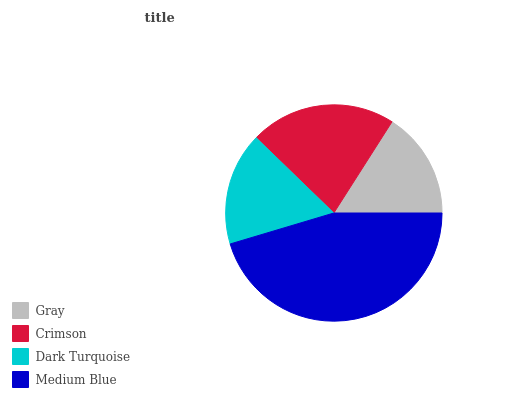Is Gray the minimum?
Answer yes or no. Yes. Is Medium Blue the maximum?
Answer yes or no. Yes. Is Crimson the minimum?
Answer yes or no. No. Is Crimson the maximum?
Answer yes or no. No. Is Crimson greater than Gray?
Answer yes or no. Yes. Is Gray less than Crimson?
Answer yes or no. Yes. Is Gray greater than Crimson?
Answer yes or no. No. Is Crimson less than Gray?
Answer yes or no. No. Is Crimson the high median?
Answer yes or no. Yes. Is Dark Turquoise the low median?
Answer yes or no. Yes. Is Gray the high median?
Answer yes or no. No. Is Crimson the low median?
Answer yes or no. No. 